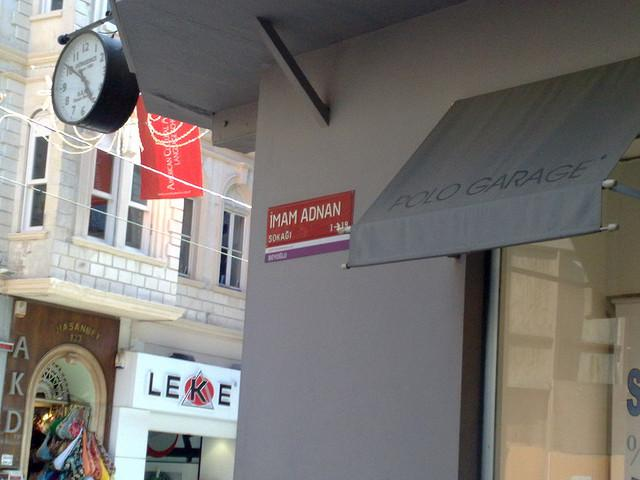What is the name of the Garage?

Choices:
A) polo
B) imam
C) leke
D) akd polo 